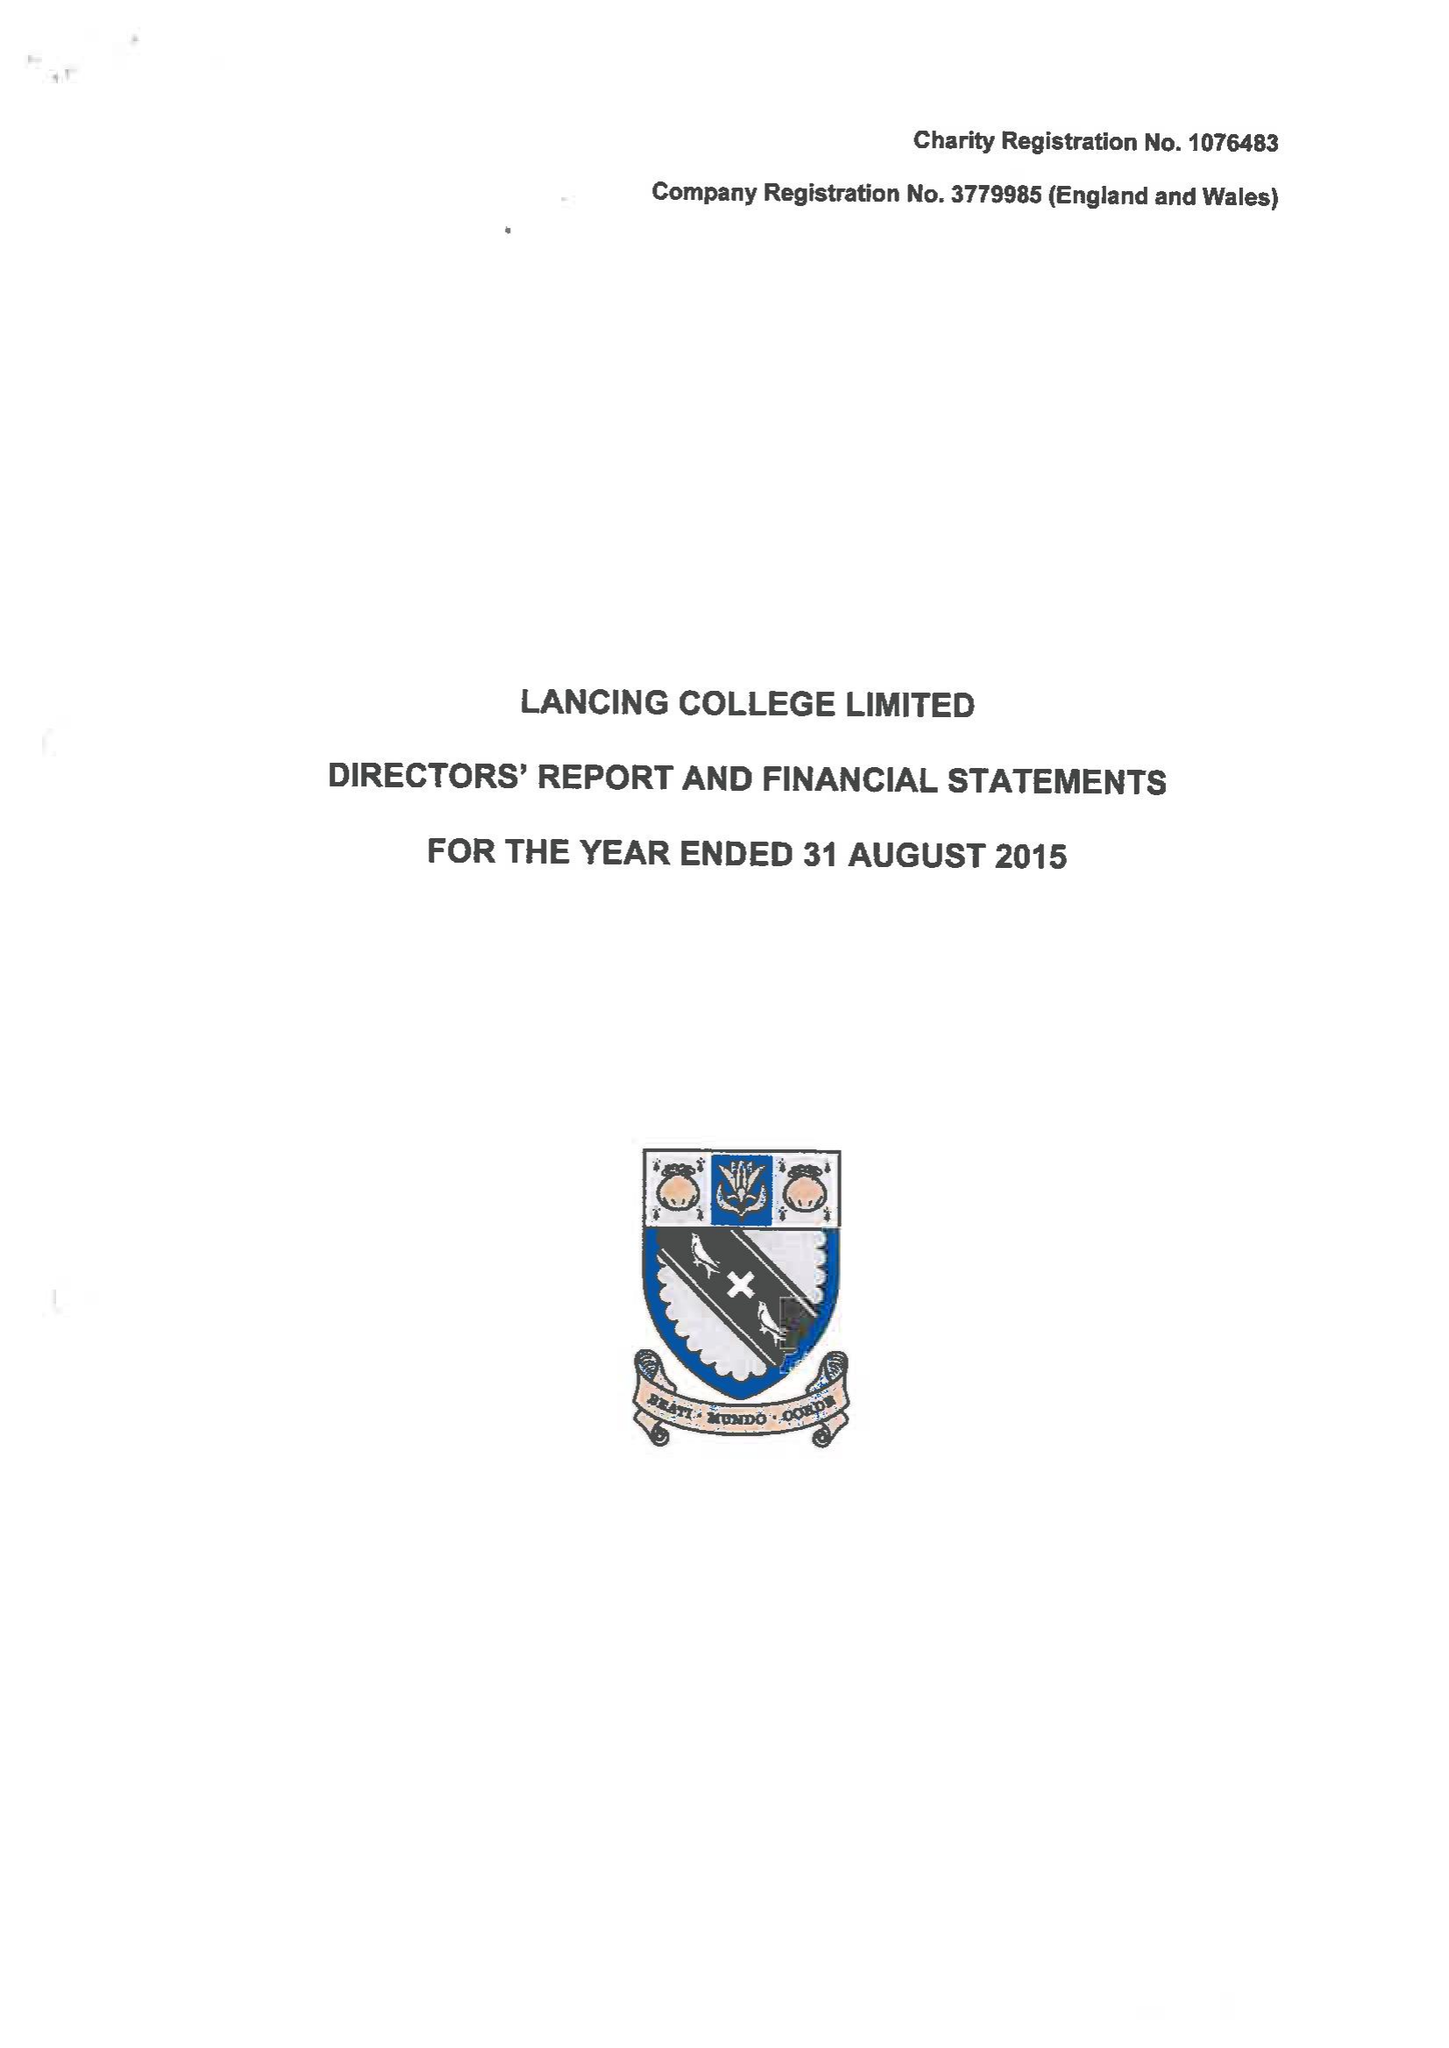What is the value for the spending_annually_in_british_pounds?
Answer the question using a single word or phrase. 18446626.00 